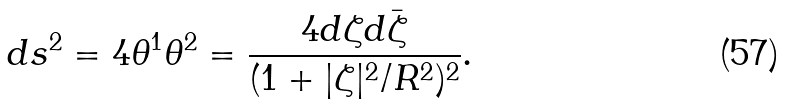Convert formula to latex. <formula><loc_0><loc_0><loc_500><loc_500>d s ^ { 2 } = 4 \theta ^ { 1 } \theta ^ { 2 } = \frac { 4 d \zeta d \bar { \zeta } } { ( 1 + | \zeta | ^ { 2 } / R ^ { 2 } ) ^ { 2 } } .</formula> 